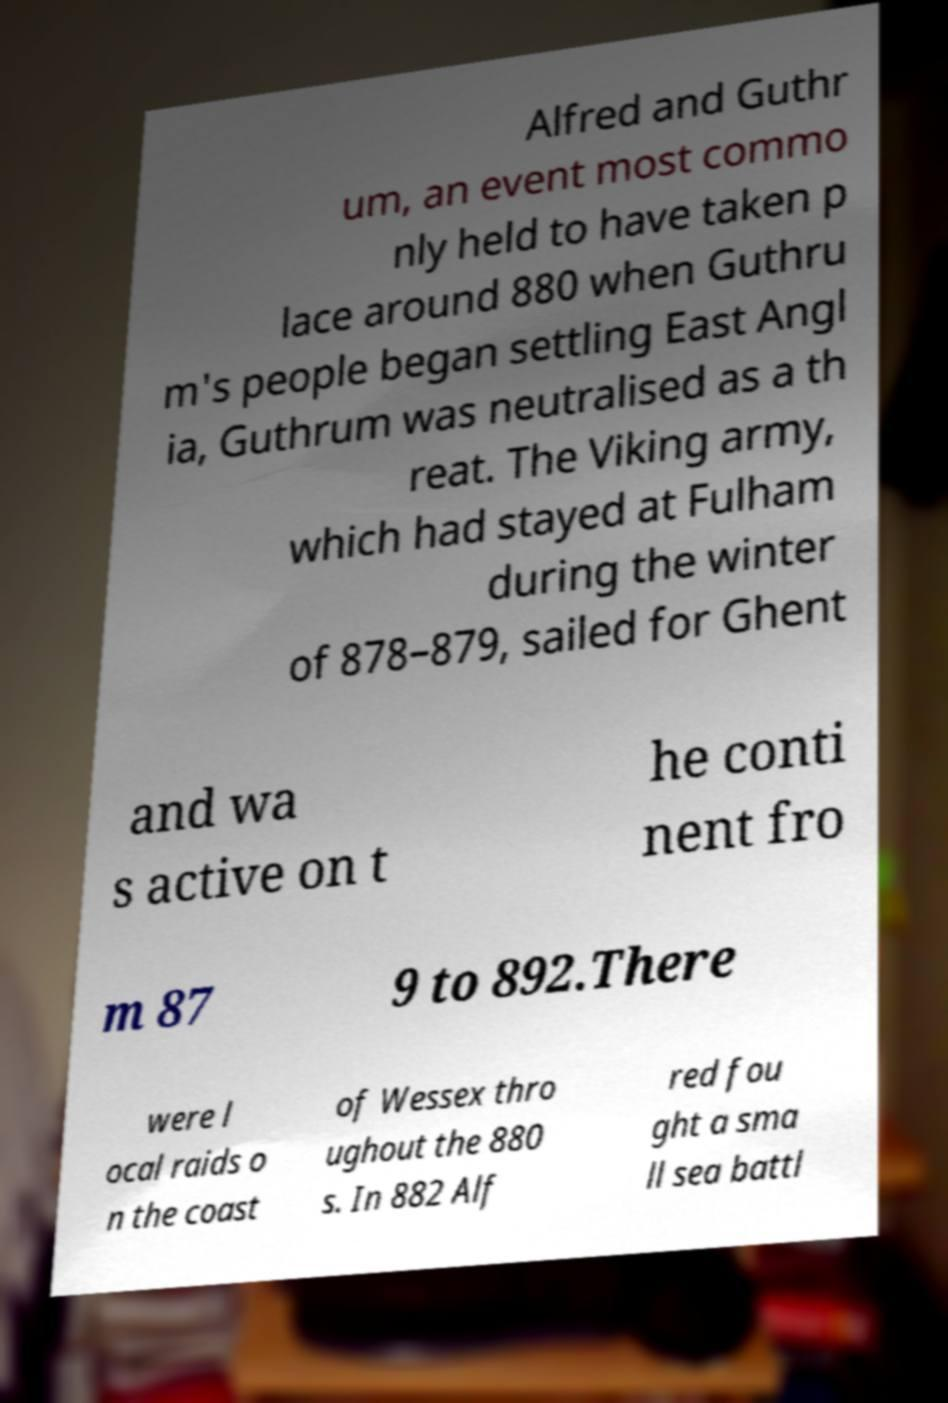For documentation purposes, I need the text within this image transcribed. Could you provide that? Alfred and Guthr um, an event most commo nly held to have taken p lace around 880 when Guthru m's people began settling East Angl ia, Guthrum was neutralised as a th reat. The Viking army, which had stayed at Fulham during the winter of 878–879, sailed for Ghent and wa s active on t he conti nent fro m 87 9 to 892.There were l ocal raids o n the coast of Wessex thro ughout the 880 s. In 882 Alf red fou ght a sma ll sea battl 